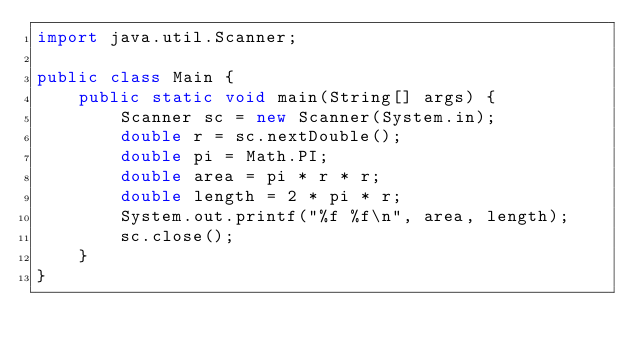<code> <loc_0><loc_0><loc_500><loc_500><_Java_>import java.util.Scanner;

public class Main {
    public static void main(String[] args) {
        Scanner sc = new Scanner(System.in);
        double r = sc.nextDouble();
        double pi = Math.PI;
        double area = pi * r * r;
        double length = 2 * pi * r;
        System.out.printf("%f %f\n", area, length);
        sc.close();
    }
}
</code> 